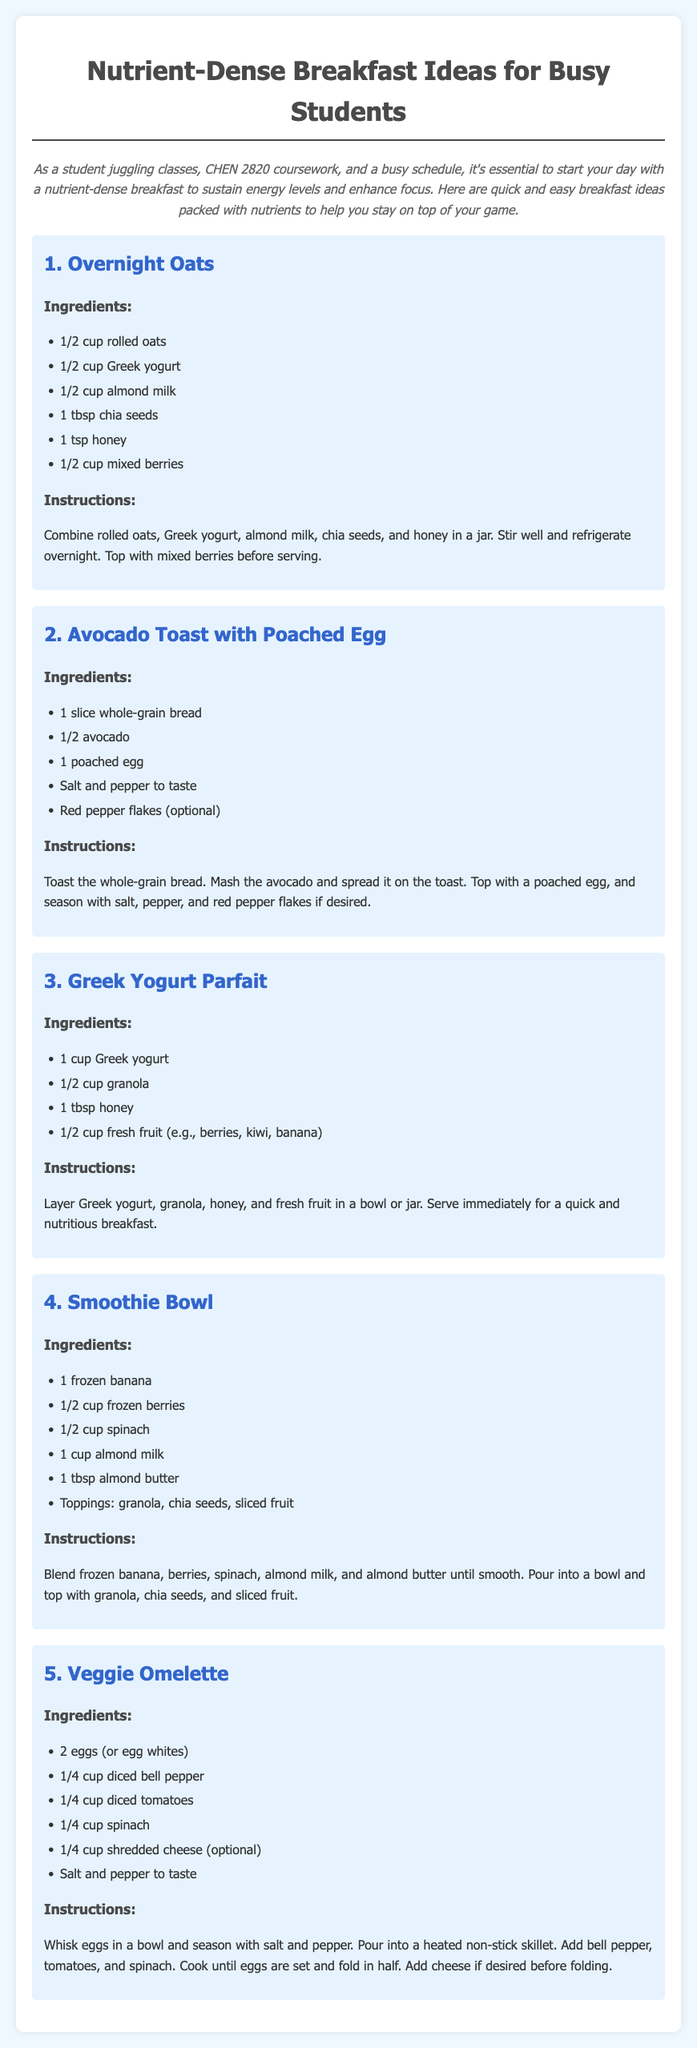What is the title of the document? The title is clearly stated at the top of the document.
Answer: Nutrient-Dense Breakfast Ideas for Busy Students How many ingredients are in Overnight Oats? Counting the listed items for Overnight Oats gives us the total number of ingredients.
Answer: 6 What is the main dairy ingredient in the Smoothie Bowl? The Smoothie Bowl includes a specific dairy product as a main ingredient.
Answer: almond milk What is an optional topping for the Smoothie Bowl? The document mentions optional items that can be added to the Smoothie Bowl.
Answer: granola What type of bread is used in the Avocado Toast? The recipe specifies the kind of bread that should be used.
Answer: whole-grain bread How many eggs are used in the Veggie Omelette? The ingredients list explicitly states how many eggs are needed for the dish.
Answer: 2 What is the main benefit of having a nutrient-dense breakfast according to the document? The document discusses the importance of starting the day with certain types of breakfasts.
Answer: sustain energy levels What should you do with the eggs in the Veggie Omelette before cooking? The instructions for cooking the Veggie Omelette describe a preparatory step for the eggs.
Answer: whisk What type of fruit is suggested for the Greek Yogurt Parfait? The ingredients list for the Greek Yogurt Parfait includes specific types of fruit.
Answer: fresh fruit (e.g., berries, kiwi, banana) 